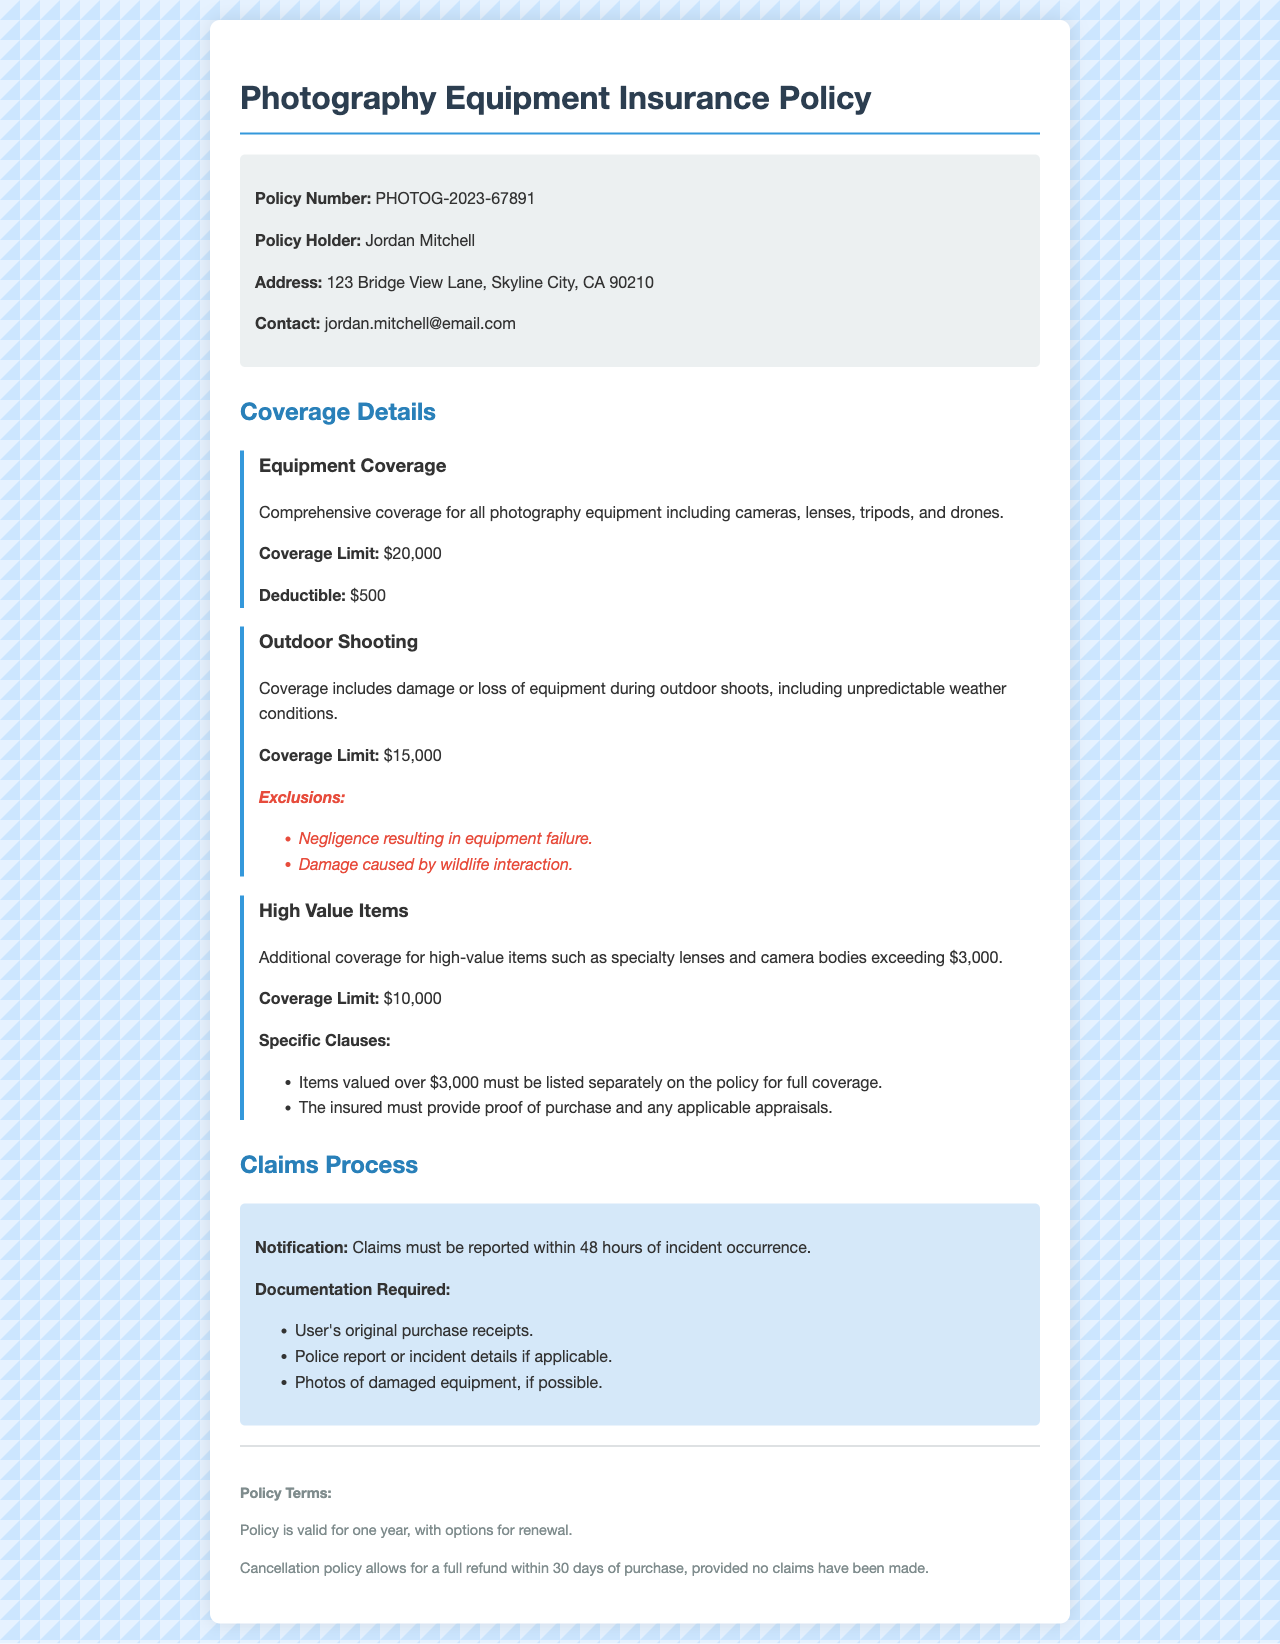What is the policy number? The policy number is listed at the top of the policy information section.
Answer: PHOTOG-2023-67891 What is the coverage limit for equipment? The coverage limit for photography equipment is stated in the coverage details section.
Answer: $20,000 What is the deductible amount? The deductible amount is specified under the equipment coverage section.
Answer: $500 What is the coverage limit for outdoor shooting? The coverage limit for outdoor shooting is mentioned in that specific section.
Answer: $15,000 What items must be listed separately for high-value coverage? The document specifies which items require separate listing for full coverage under high-value coverage.
Answer: Specialty lenses and camera bodies exceeding $3,000 What is the notification period for claims? The notification period is outlined in the claims process section of the document.
Answer: 48 hours Which damages are excluded for outdoor shooting? The exclusions for outdoor shooting coverage are provided in a list format in the respective section.
Answer: Negligence resulting in equipment failure and damage caused by wildlife interaction What documentation is required for claims? Essential documents for claims are detailed in the claims process section.
Answer: User's original purchase receipts, police report, and photos of damaged equipment What is the duration of the policy validity? The policy duration is stated in the policy terms section of the document.
Answer: One year 